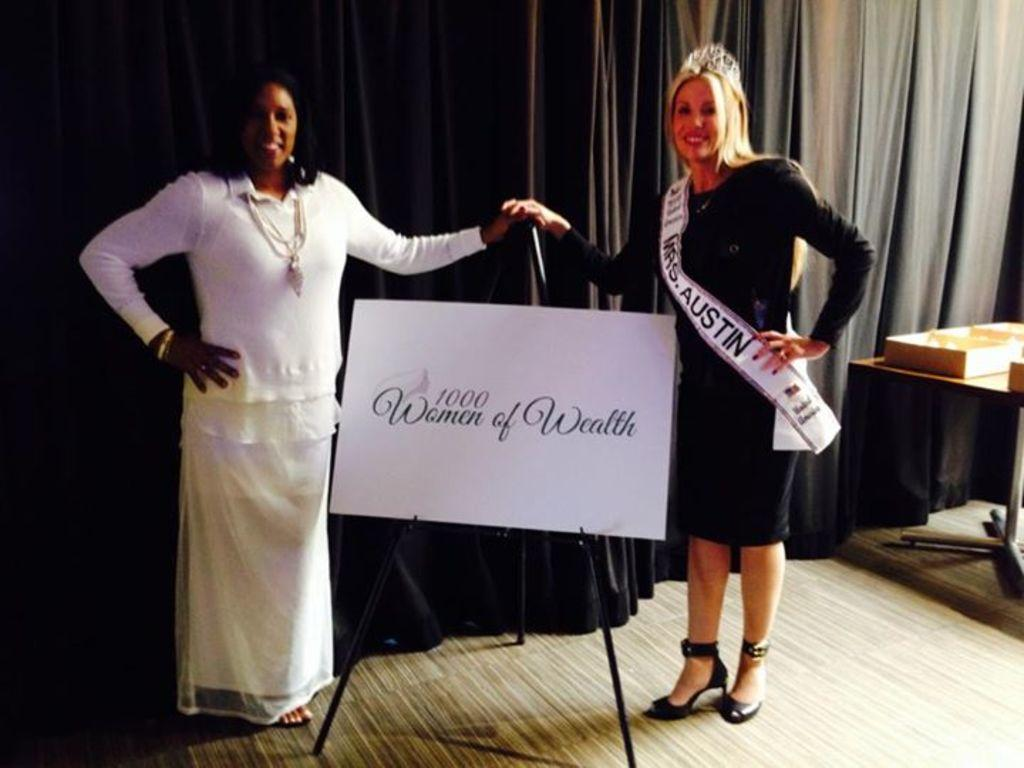How many people are in the image? There are two women in the image. What are the women doing in the image? The women are standing and smiling. What are the women holding in the image? The women are holding a board. What can be seen in the background of the image? There is a curtain in the background of the image. What is present on the right side of the image? There is a cart board on a table in the right side of the image. Who is the owner of the pocket in the image? There is no pocket present in the image. How many passengers are visible in the image? There are no passengers visible in the image, as it only features two women. 